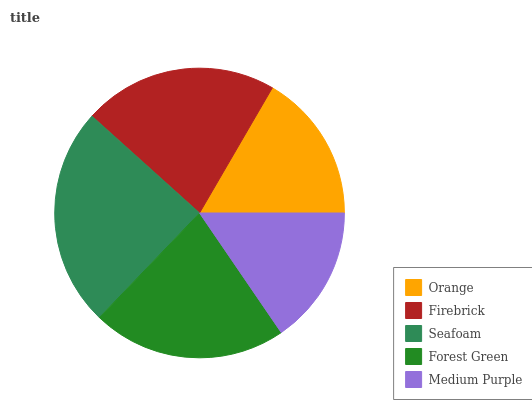Is Medium Purple the minimum?
Answer yes or no. Yes. Is Seafoam the maximum?
Answer yes or no. Yes. Is Firebrick the minimum?
Answer yes or no. No. Is Firebrick the maximum?
Answer yes or no. No. Is Firebrick greater than Orange?
Answer yes or no. Yes. Is Orange less than Firebrick?
Answer yes or no. Yes. Is Orange greater than Firebrick?
Answer yes or no. No. Is Firebrick less than Orange?
Answer yes or no. No. Is Forest Green the high median?
Answer yes or no. Yes. Is Forest Green the low median?
Answer yes or no. Yes. Is Orange the high median?
Answer yes or no. No. Is Orange the low median?
Answer yes or no. No. 